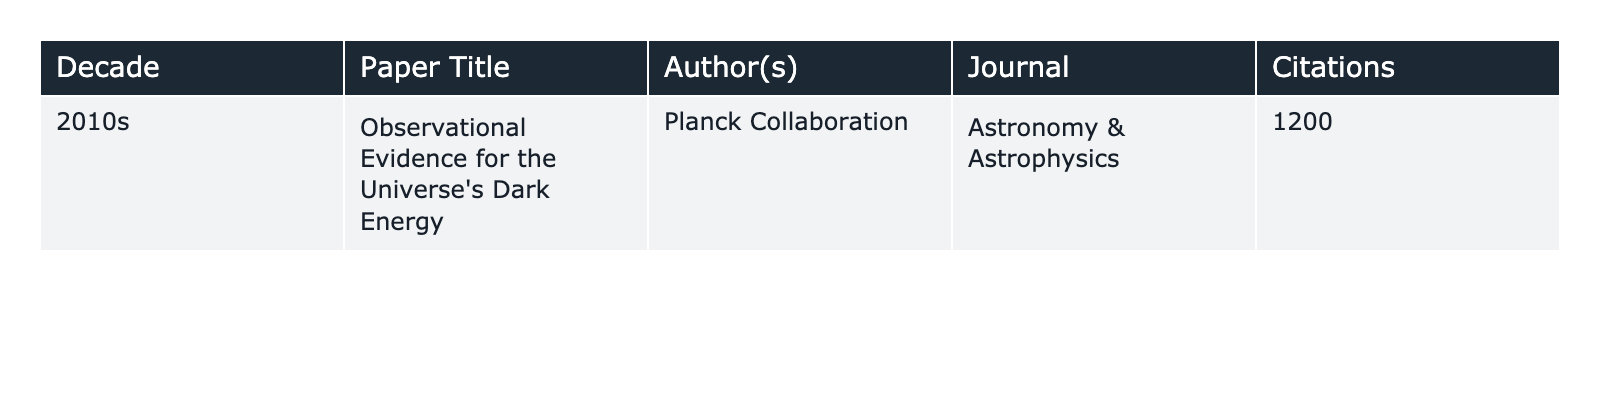What is the title of the paper with the most citations in the table? The table shows only one paper, which is "Observational Evidence for the Universe's Dark Energy" by the Planck Collaboration.
Answer: "Observational Evidence for the Universe's Dark Energy" Who is the author of the paper listed in the table? The only author listed in the table is the Planck Collaboration.
Answer: Planck Collaboration In which journal is the paper "Observational Evidence for the Universe's Dark Energy" published? The journal mentioned in the table for this paper is "Astronomy & Astrophysics".
Answer: Astronomy & Astrophysics How many citations does the paper from the 2010s have? According to the table, the paper has a total of 1200 citations.
Answer: 1200 Is it true that the paper from the 2010s has more than 1000 citations? The table indicates that the paper has 1200 citations, which is indeed more than 1000.
Answer: True What decade does the paper "Observational Evidence for the Universe's Dark Energy" belong to? The table specifies that this paper belongs to the 2010s decade.
Answer: 2010s If we consider only the data presented, what is the average number of citations per decade? There is only one entry in the table for the 2010s with 1200 citations, so the average is 1200/1 = 1200.
Answer: 1200 Can you determine a trend in citations over decades based on the provided data? The table contains data for only one decade (2010s), so there is insufficient information to determine a citation trend.
Answer: No What is the difference in citations between the paper in the 2010s and a hypothetical paper with 800 citations? The difference between 1200 (the actual paper's citations) and 800 (the hypothetical paper) is 1200 - 800 = 400.
Answer: 400 If all major papers from the 2010s had citations equal to the given paper, how many citations would there be if there were 5 such papers? If there were 5 papers each with 1200 citations, the total would be 5 * 1200 = 6000 citations.
Answer: 6000 